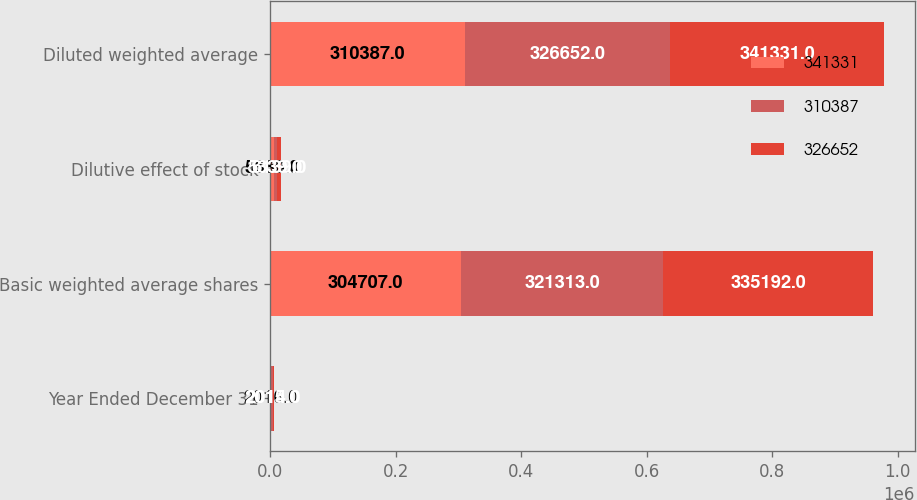Convert chart. <chart><loc_0><loc_0><loc_500><loc_500><stacked_bar_chart><ecel><fcel>Year Ended December 31<fcel>Basic weighted average shares<fcel>Dilutive effect of stock<fcel>Diluted weighted average<nl><fcel>341331<fcel>2016<fcel>304707<fcel>5680<fcel>310387<nl><fcel>310387<fcel>2015<fcel>321313<fcel>5339<fcel>326652<nl><fcel>326652<fcel>2014<fcel>335192<fcel>6139<fcel>341331<nl></chart> 